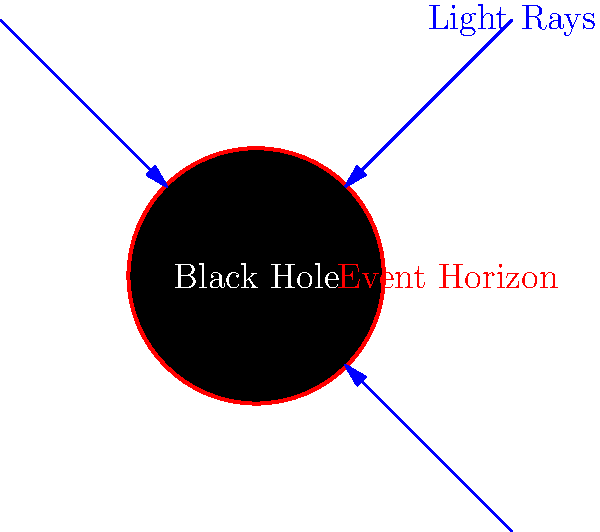As a motion graphic artist experienced in horror and mystery films, how would you visually represent the concept of a black hole's event horizon in a 2D graphic? Specifically, what key elements should be included to accurately convey the behavior of light near this boundary? To visually represent a black hole's event horizon in a 2D graphic, consider the following key elements:

1. Black Hole Center: Represent the black hole as a solid black circle at the center of the graphic. This symbolizes the singularity and the region of no return.

2. Event Horizon: Draw a distinct red circle around the black hole to represent the event horizon. This is the boundary beyond which nothing, not even light, can escape the black hole's gravitational pull.

3. Light Rays: Include blue arrows representing light rays approaching the black hole from different directions. These should be drawn as:
   a) Rays that don't come close to the event horizon, passing by unaffected.
   b) Rays that come close to the event horizon but still manage to escape, showing a curved path due to gravitational lensing.
   c) Rays that cross the event horizon, terminating at the boundary to show they cannot escape.

4. Space Distortion: Although challenging in 2D, you can hint at the warping of spacetime by slightly curving the background or adding subtle distortion effects near the event horizon.

5. Accretion Disk (optional): For added visual interest, you could include a colorful accretion disk around the black hole, representing the superheated matter swirling around before falling in.

6. Labels: Add clear labels for the black hole, event horizon, and light rays to ensure the audience understands each element.

This representation effectively communicates the key concepts of a black hole's event horizon while maintaining a visually striking and somewhat ominous appearance, fitting for your background in horror and mystery films.
Answer: Black circle for hole, red circle for event horizon, blue arrows for light rays (some escaping, some trapped), optional accretion disk, and clear labels. 